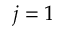<formula> <loc_0><loc_0><loc_500><loc_500>j = 1</formula> 